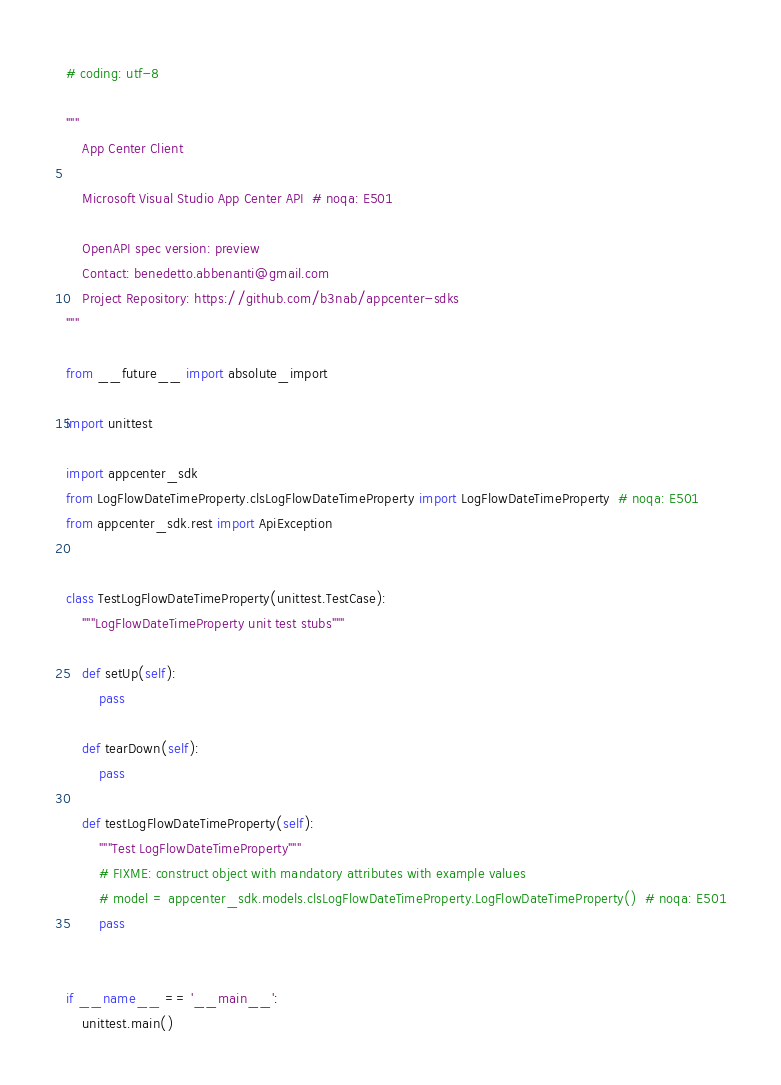<code> <loc_0><loc_0><loc_500><loc_500><_Python_># coding: utf-8

"""
    App Center Client

    Microsoft Visual Studio App Center API  # noqa: E501

    OpenAPI spec version: preview
    Contact: benedetto.abbenanti@gmail.com
    Project Repository: https://github.com/b3nab/appcenter-sdks
"""

from __future__ import absolute_import

import unittest

import appcenter_sdk
from LogFlowDateTimeProperty.clsLogFlowDateTimeProperty import LogFlowDateTimeProperty  # noqa: E501
from appcenter_sdk.rest import ApiException


class TestLogFlowDateTimeProperty(unittest.TestCase):
    """LogFlowDateTimeProperty unit test stubs"""

    def setUp(self):
        pass

    def tearDown(self):
        pass

    def testLogFlowDateTimeProperty(self):
        """Test LogFlowDateTimeProperty"""
        # FIXME: construct object with mandatory attributes with example values
        # model = appcenter_sdk.models.clsLogFlowDateTimeProperty.LogFlowDateTimeProperty()  # noqa: E501
        pass


if __name__ == '__main__':
    unittest.main()
</code> 